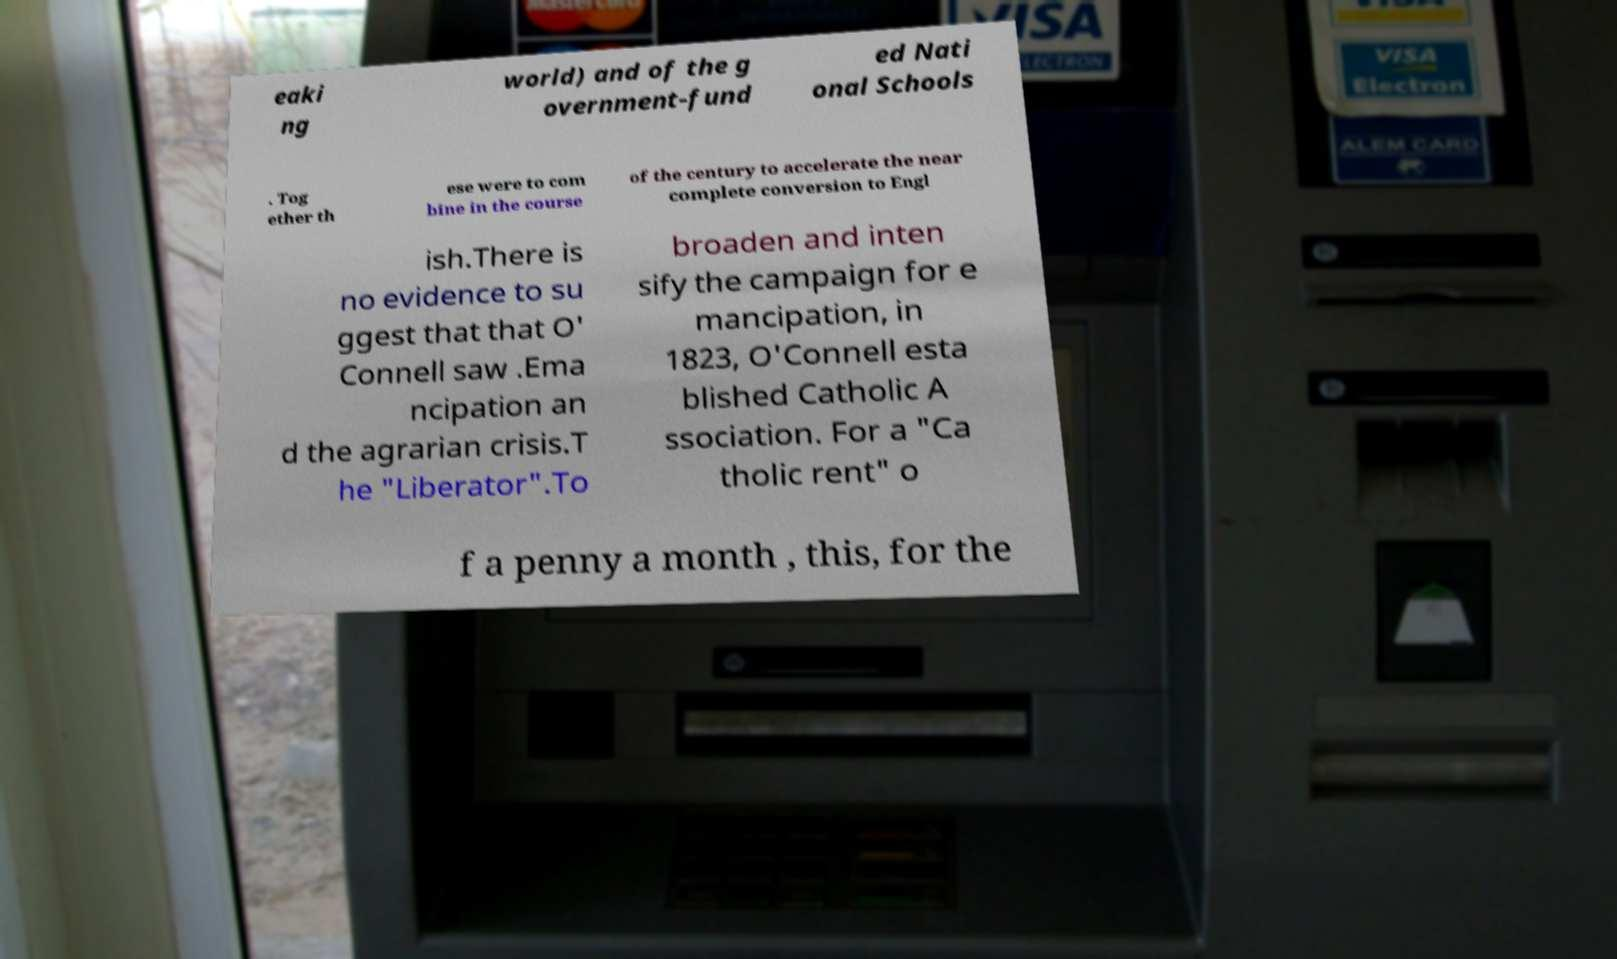I need the written content from this picture converted into text. Can you do that? eaki ng world) and of the g overnment-fund ed Nati onal Schools . Tog ether th ese were to com bine in the course of the century to accelerate the near complete conversion to Engl ish.There is no evidence to su ggest that that O' Connell saw .Ema ncipation an d the agrarian crisis.T he "Liberator".To broaden and inten sify the campaign for e mancipation, in 1823, O'Connell esta blished Catholic A ssociation. For a "Ca tholic rent" o f a penny a month , this, for the 